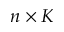<formula> <loc_0><loc_0><loc_500><loc_500>n \times K</formula> 